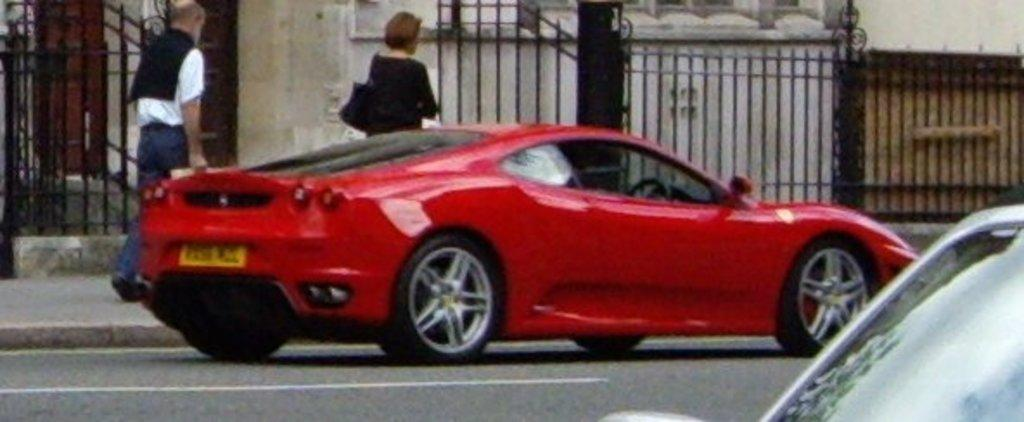What type of vehicles can be seen on the road in the image? There are cars on the road in the image. Can you identify any living beings in the image? Yes, there are people visible in the image. What type of barrier can be seen in the image? There is a fence in the image. What type of structure can be seen in the image? There is a wall in the image. Can you tell me how many cubs are playing on the wall in the image? There are no cubs present in the image; it features cars on the road, people, a fence, and a wall. Are there any individuals swimming in the image? There is no swimming activity depicted in the image. 